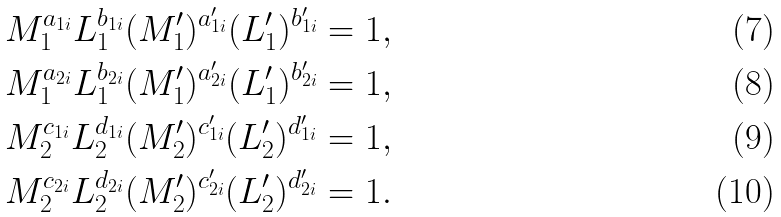Convert formula to latex. <formula><loc_0><loc_0><loc_500><loc_500>M _ { 1 } ^ { a _ { 1 i } } L _ { 1 } ^ { b _ { 1 i } } ( M ^ { \prime } _ { 1 } ) ^ { a ^ { \prime } _ { 1 i } } ( L ^ { \prime } _ { 1 } ) ^ { b ^ { \prime } _ { 1 i } } = 1 , \\ M _ { 1 } ^ { a _ { 2 i } } L _ { 1 } ^ { b _ { 2 i } } ( M ^ { \prime } _ { 1 } ) ^ { a ^ { \prime } _ { 2 i } } ( L ^ { \prime } _ { 1 } ) ^ { b ^ { \prime } _ { 2 i } } = 1 , \\ M _ { 2 } ^ { c _ { 1 i } } L _ { 2 } ^ { d _ { 1 i } } ( M ^ { \prime } _ { 2 } ) ^ { c ^ { \prime } _ { 1 i } } ( L ^ { \prime } _ { 2 } ) ^ { d ^ { \prime } _ { 1 i } } = 1 , \\ M _ { 2 } ^ { c _ { 2 i } } L _ { 2 } ^ { d _ { 2 i } } ( M ^ { \prime } _ { 2 } ) ^ { c ^ { \prime } _ { 2 i } } ( L ^ { \prime } _ { 2 } ) ^ { d ^ { \prime } _ { 2 i } } = 1 .</formula> 